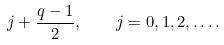Convert formula to latex. <formula><loc_0><loc_0><loc_500><loc_500>j + { \frac { q - 1 } 2 } , \quad j = 0 , 1 , 2 , \dots .</formula> 